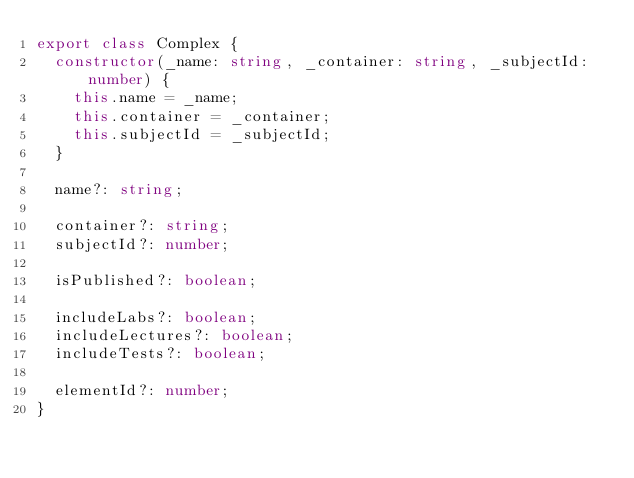Convert code to text. <code><loc_0><loc_0><loc_500><loc_500><_TypeScript_>export class Complex {
  constructor(_name: string, _container: string, _subjectId: number) {
    this.name = _name;
    this.container = _container;
    this.subjectId = _subjectId;
  }

  name?: string;

  container?: string;
  subjectId?: number;

  isPublished?: boolean;

  includeLabs?: boolean;
  includeLectures?: boolean;
  includeTests?: boolean;

  elementId?: number; 
}
</code> 